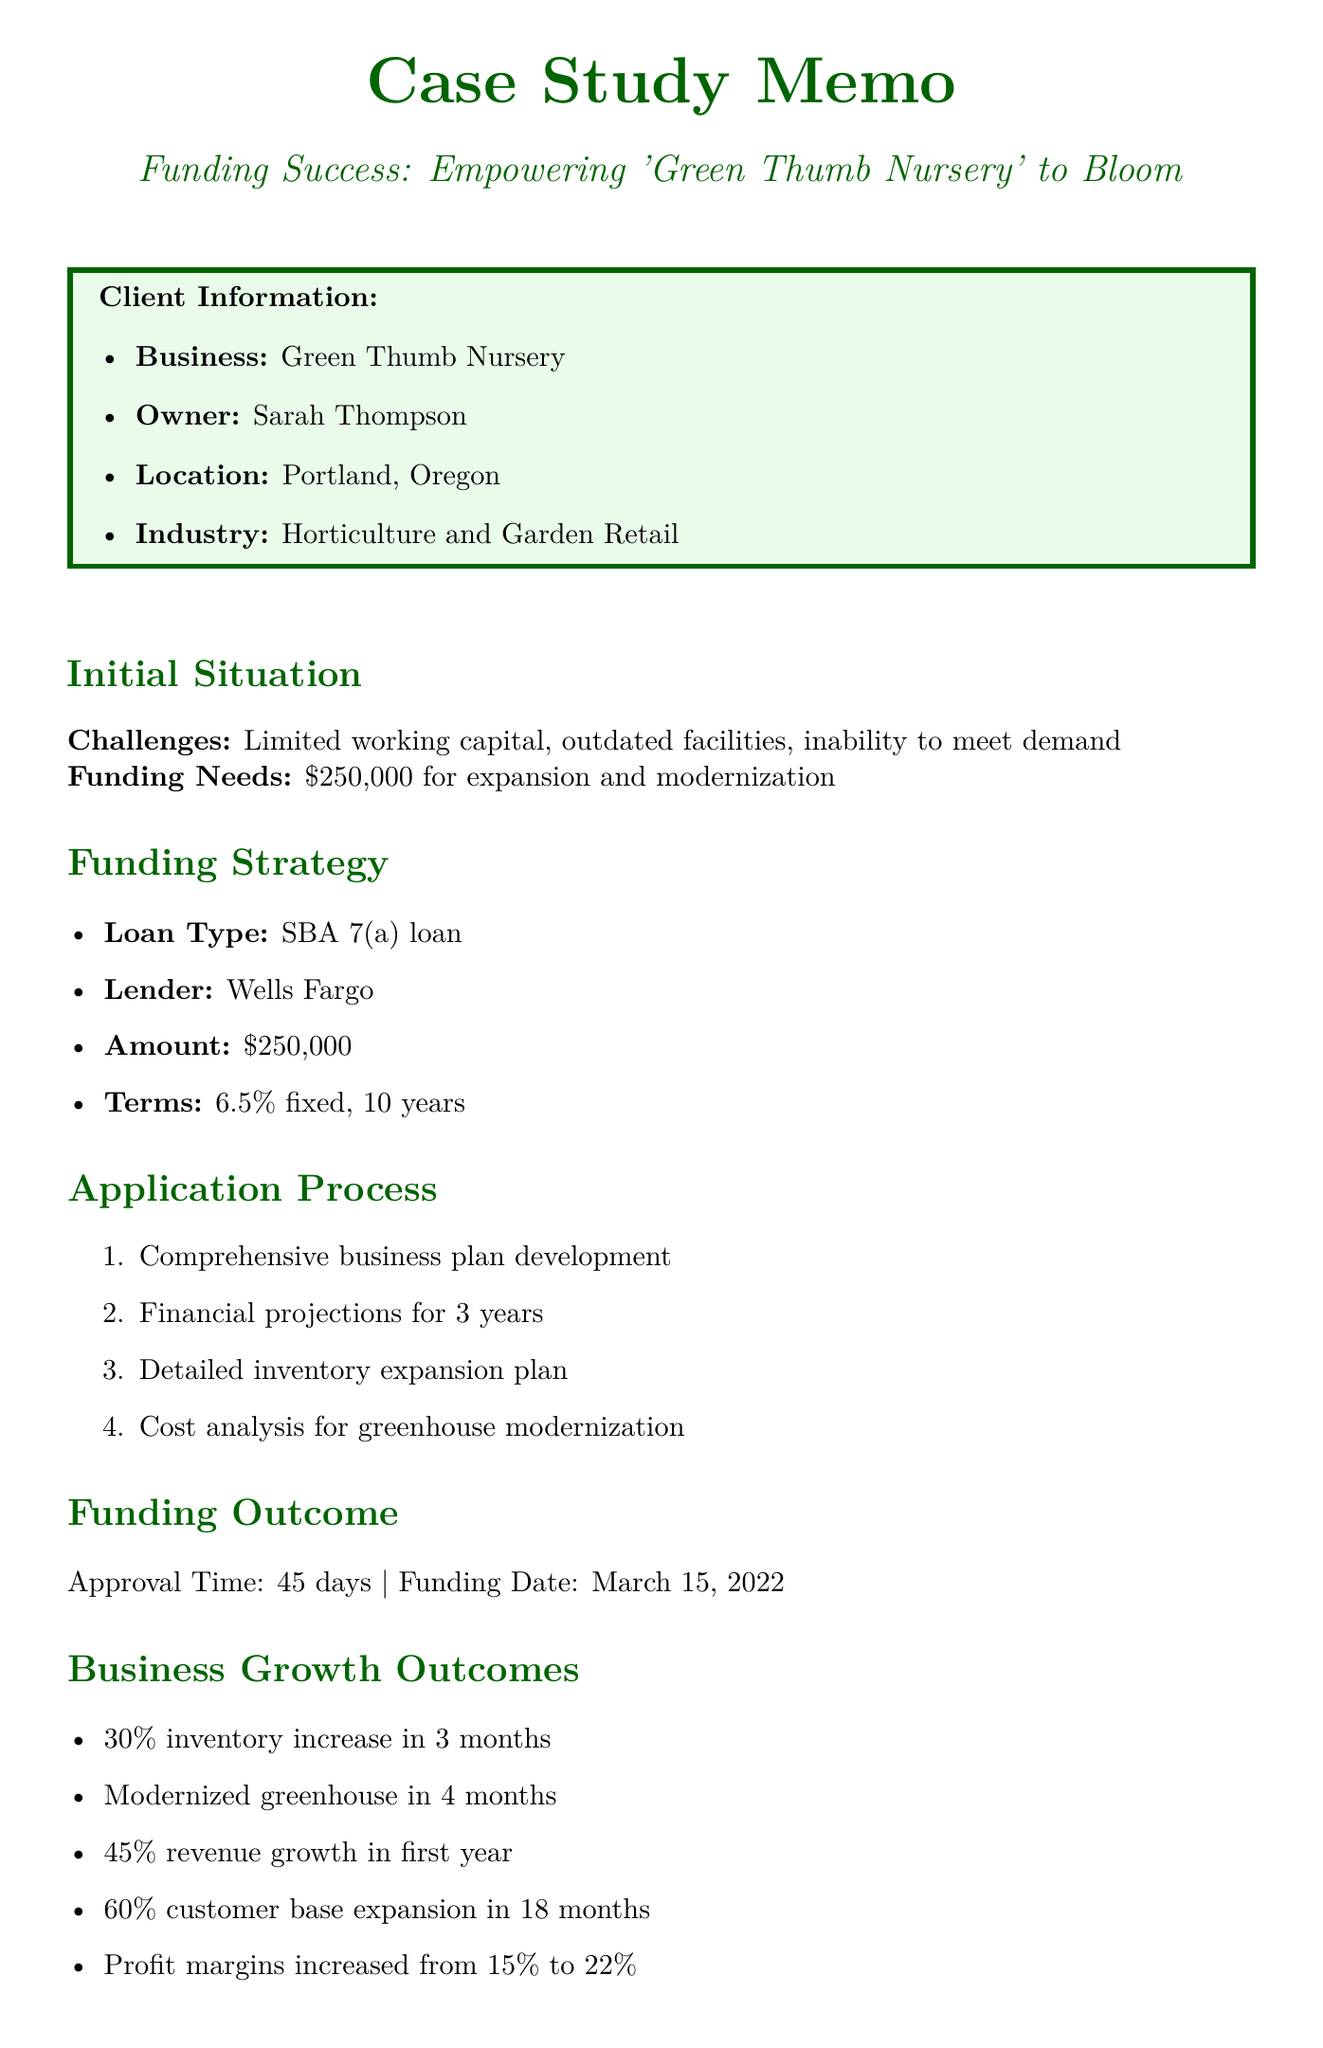What is the business name? The business name is listed in the client information section of the document.
Answer: Green Thumb Nursery Who is the owner? The owner's name is provided in the client information section of the document.
Answer: Sarah Thompson What is the funding amount needed? The funding amount needed is specified in the initial situation section.
Answer: $250,000 What type of loan was obtained? The type of loan is mentioned in the funding strategy section.
Answer: SBA 7(a) loan What was the funding date? The funding date is mentioned under the funding outcome section.
Answer: March 15, 2022 What was the revenue growth in the first year post-funding? The revenue growth is discussed in the long-term business growth outcomes.
Answer: 45% How many new employees were hired? The number of new employees hired is mentioned in the short-term business growth outcomes.
Answer: 3 What was the interest rate for the loan? The interest rate is listed in the funding strategy section of the document.
Answer: 6.5% fixed What is one key lesson learned? The key lessons learned are summarized in a specific section of the document.
Answer: Importance of a well-prepared business plan 